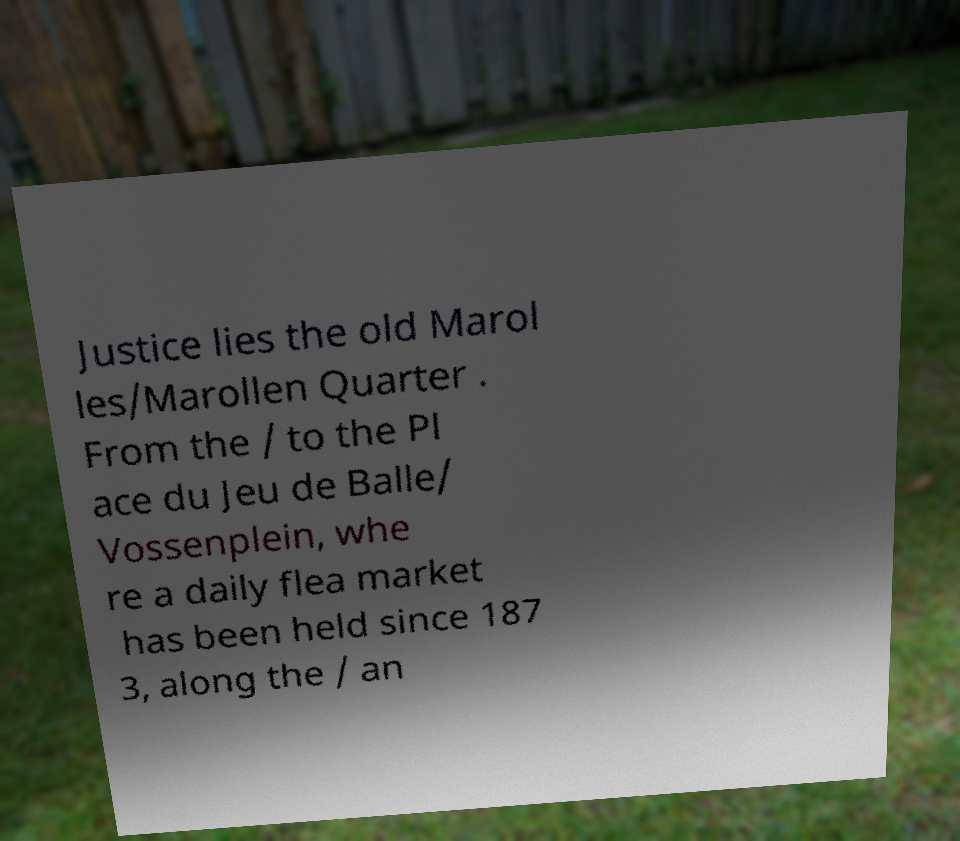I need the written content from this picture converted into text. Can you do that? Justice lies the old Marol les/Marollen Quarter . From the / to the Pl ace du Jeu de Balle/ Vossenplein, whe re a daily flea market has been held since 187 3, along the / an 